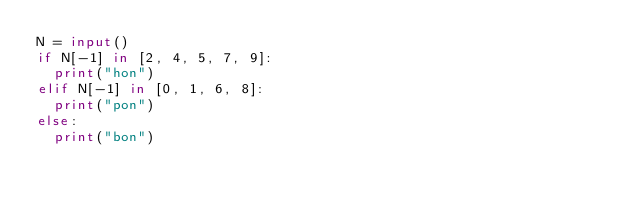<code> <loc_0><loc_0><loc_500><loc_500><_Python_>N = input()
if N[-1] in [2, 4, 5, 7, 9]:
  print("hon")
elif N[-1] in [0, 1, 6, 8]:
  print("pon")
else:
  print("bon")</code> 